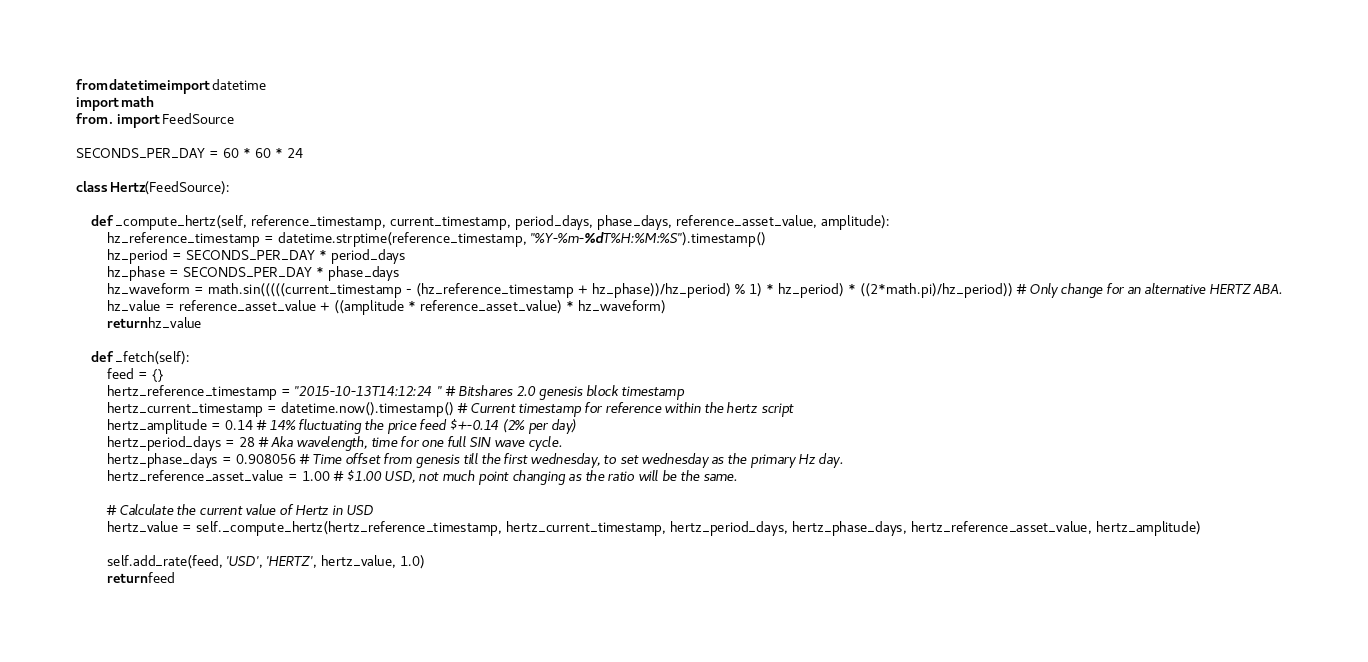Convert code to text. <code><loc_0><loc_0><loc_500><loc_500><_Python_>from datetime import datetime
import math
from . import FeedSource

SECONDS_PER_DAY = 60 * 60 * 24

class Hertz(FeedSource):

    def _compute_hertz(self, reference_timestamp, current_timestamp, period_days, phase_days, reference_asset_value, amplitude):
        hz_reference_timestamp = datetime.strptime(reference_timestamp, "%Y-%m-%dT%H:%M:%S").timestamp()
        hz_period = SECONDS_PER_DAY * period_days
        hz_phase = SECONDS_PER_DAY * phase_days
        hz_waveform = math.sin(((((current_timestamp - (hz_reference_timestamp + hz_phase))/hz_period) % 1) * hz_period) * ((2*math.pi)/hz_period)) # Only change for an alternative HERTZ ABA.
        hz_value = reference_asset_value + ((amplitude * reference_asset_value) * hz_waveform)
        return hz_value
    
    def _fetch(self):
        feed = {}
        hertz_reference_timestamp = "2015-10-13T14:12:24" # Bitshares 2.0 genesis block timestamp
        hertz_current_timestamp = datetime.now().timestamp() # Current timestamp for reference within the hertz script
        hertz_amplitude = 0.14 # 14% fluctuating the price feed $+-0.14 (2% per day)
        hertz_period_days = 28 # Aka wavelength, time for one full SIN wave cycle.
        hertz_phase_days = 0.908056 # Time offset from genesis till the first wednesday, to set wednesday as the primary Hz day.
        hertz_reference_asset_value = 1.00 # $1.00 USD, not much point changing as the ratio will be the same.

        # Calculate the current value of Hertz in USD
        hertz_value = self._compute_hertz(hertz_reference_timestamp, hertz_current_timestamp, hertz_period_days, hertz_phase_days, hertz_reference_asset_value, hertz_amplitude)

        self.add_rate(feed, 'USD', 'HERTZ', hertz_value, 1.0)
        return feed
</code> 